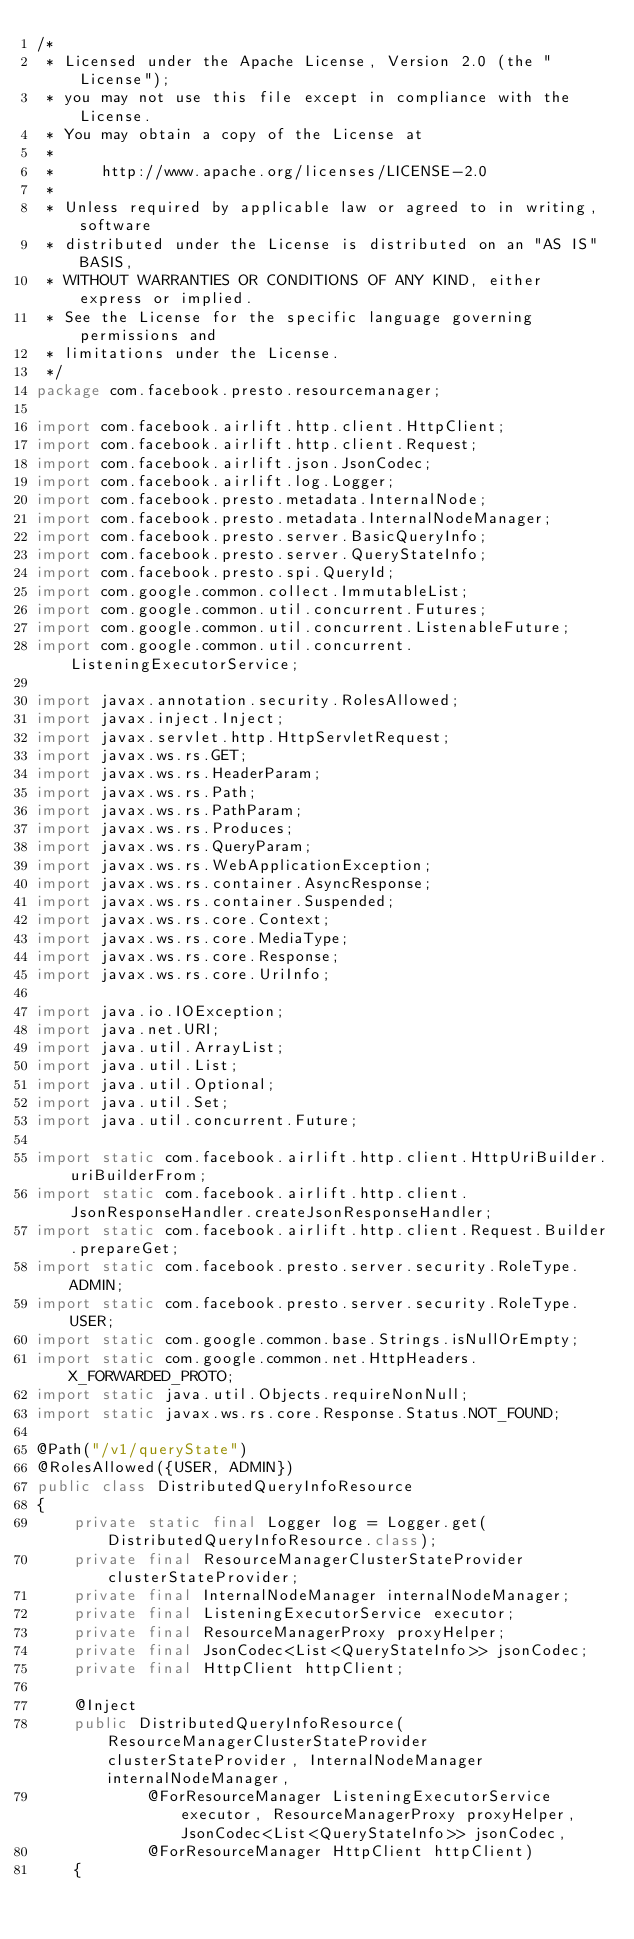Convert code to text. <code><loc_0><loc_0><loc_500><loc_500><_Java_>/*
 * Licensed under the Apache License, Version 2.0 (the "License");
 * you may not use this file except in compliance with the License.
 * You may obtain a copy of the License at
 *
 *     http://www.apache.org/licenses/LICENSE-2.0
 *
 * Unless required by applicable law or agreed to in writing, software
 * distributed under the License is distributed on an "AS IS" BASIS,
 * WITHOUT WARRANTIES OR CONDITIONS OF ANY KIND, either express or implied.
 * See the License for the specific language governing permissions and
 * limitations under the License.
 */
package com.facebook.presto.resourcemanager;

import com.facebook.airlift.http.client.HttpClient;
import com.facebook.airlift.http.client.Request;
import com.facebook.airlift.json.JsonCodec;
import com.facebook.airlift.log.Logger;
import com.facebook.presto.metadata.InternalNode;
import com.facebook.presto.metadata.InternalNodeManager;
import com.facebook.presto.server.BasicQueryInfo;
import com.facebook.presto.server.QueryStateInfo;
import com.facebook.presto.spi.QueryId;
import com.google.common.collect.ImmutableList;
import com.google.common.util.concurrent.Futures;
import com.google.common.util.concurrent.ListenableFuture;
import com.google.common.util.concurrent.ListeningExecutorService;

import javax.annotation.security.RolesAllowed;
import javax.inject.Inject;
import javax.servlet.http.HttpServletRequest;
import javax.ws.rs.GET;
import javax.ws.rs.HeaderParam;
import javax.ws.rs.Path;
import javax.ws.rs.PathParam;
import javax.ws.rs.Produces;
import javax.ws.rs.QueryParam;
import javax.ws.rs.WebApplicationException;
import javax.ws.rs.container.AsyncResponse;
import javax.ws.rs.container.Suspended;
import javax.ws.rs.core.Context;
import javax.ws.rs.core.MediaType;
import javax.ws.rs.core.Response;
import javax.ws.rs.core.UriInfo;

import java.io.IOException;
import java.net.URI;
import java.util.ArrayList;
import java.util.List;
import java.util.Optional;
import java.util.Set;
import java.util.concurrent.Future;

import static com.facebook.airlift.http.client.HttpUriBuilder.uriBuilderFrom;
import static com.facebook.airlift.http.client.JsonResponseHandler.createJsonResponseHandler;
import static com.facebook.airlift.http.client.Request.Builder.prepareGet;
import static com.facebook.presto.server.security.RoleType.ADMIN;
import static com.facebook.presto.server.security.RoleType.USER;
import static com.google.common.base.Strings.isNullOrEmpty;
import static com.google.common.net.HttpHeaders.X_FORWARDED_PROTO;
import static java.util.Objects.requireNonNull;
import static javax.ws.rs.core.Response.Status.NOT_FOUND;

@Path("/v1/queryState")
@RolesAllowed({USER, ADMIN})
public class DistributedQueryInfoResource
{
    private static final Logger log = Logger.get(DistributedQueryInfoResource.class);
    private final ResourceManagerClusterStateProvider clusterStateProvider;
    private final InternalNodeManager internalNodeManager;
    private final ListeningExecutorService executor;
    private final ResourceManagerProxy proxyHelper;
    private final JsonCodec<List<QueryStateInfo>> jsonCodec;
    private final HttpClient httpClient;

    @Inject
    public DistributedQueryInfoResource(ResourceManagerClusterStateProvider clusterStateProvider, InternalNodeManager internalNodeManager,
            @ForResourceManager ListeningExecutorService executor, ResourceManagerProxy proxyHelper, JsonCodec<List<QueryStateInfo>> jsonCodec,
            @ForResourceManager HttpClient httpClient)
    {</code> 